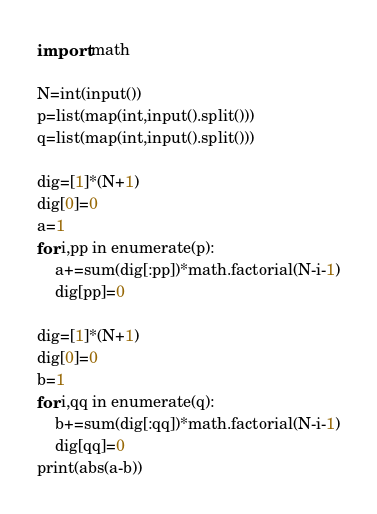<code> <loc_0><loc_0><loc_500><loc_500><_Python_>import math

N=int(input())
p=list(map(int,input().split()))
q=list(map(int,input().split()))

dig=[1]*(N+1)
dig[0]=0
a=1
for i,pp in enumerate(p):
    a+=sum(dig[:pp])*math.factorial(N-i-1)
    dig[pp]=0

dig=[1]*(N+1)
dig[0]=0
b=1
for i,qq in enumerate(q):
    b+=sum(dig[:qq])*math.factorial(N-i-1)
    dig[qq]=0
print(abs(a-b))
</code> 